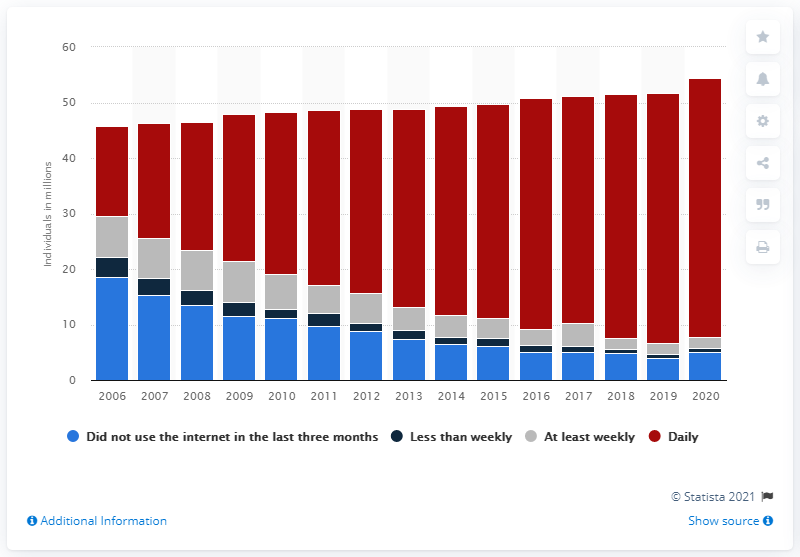Highlight a few significant elements in this photo. It is estimated that approximately 5% of Britons had not used the internet in the past three months. In 2006, it was reported that 18.5% of Britons had not used the internet in the past three months. 